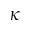<formula> <loc_0><loc_0><loc_500><loc_500>\kappa</formula> 